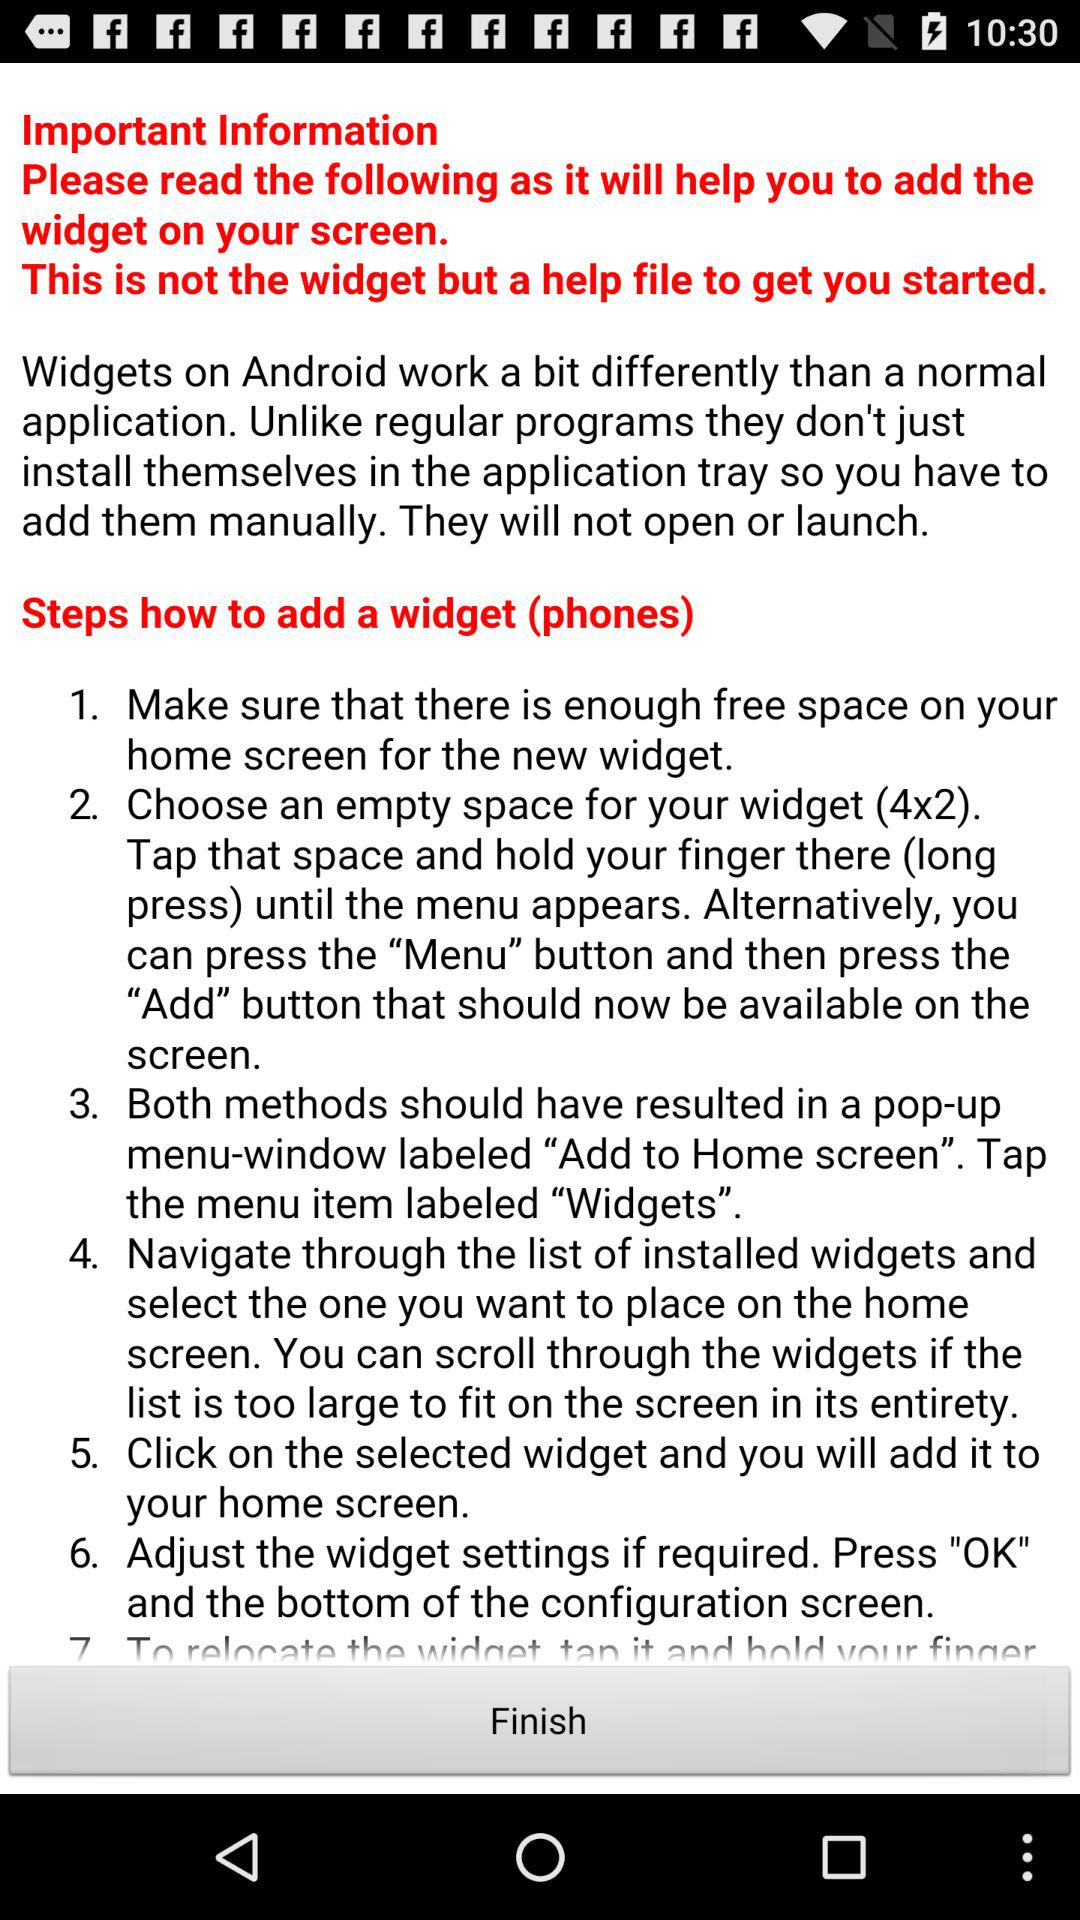How many steps are there to add a widget?
Answer the question using a single word or phrase. 7 